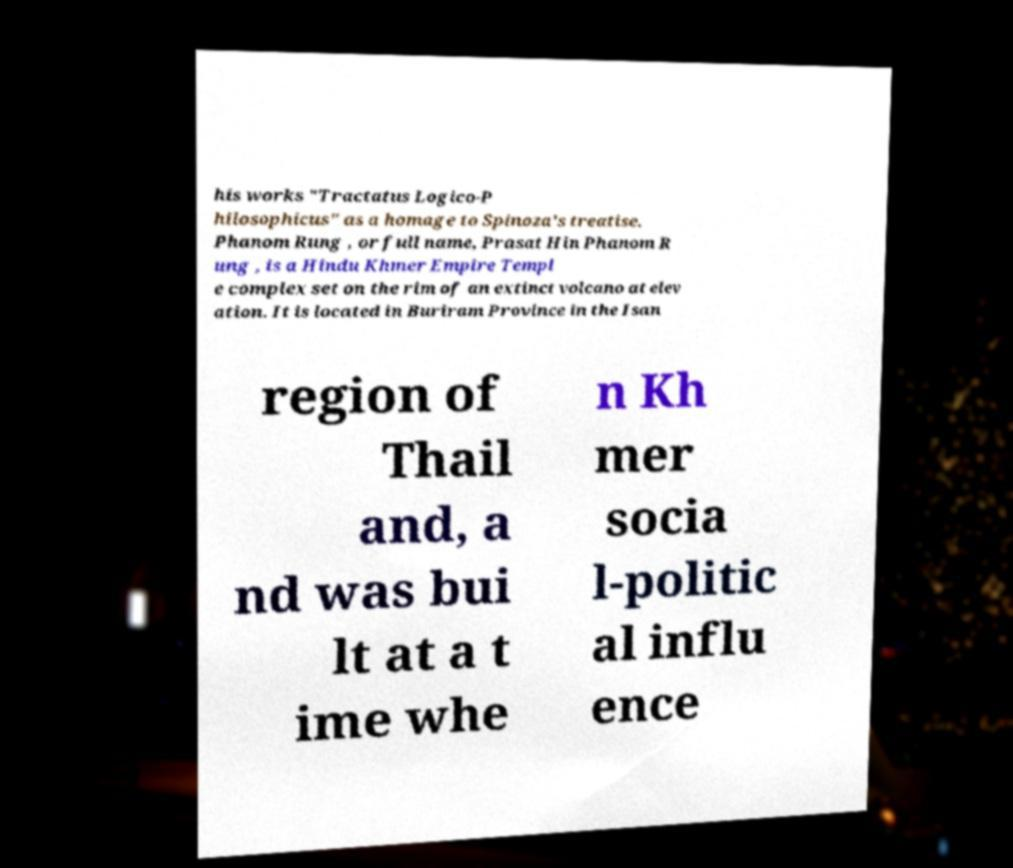What messages or text are displayed in this image? I need them in a readable, typed format. his works "Tractatus Logico-P hilosophicus" as a homage to Spinoza's treatise. Phanom Rung , or full name, Prasat Hin Phanom R ung , is a Hindu Khmer Empire Templ e complex set on the rim of an extinct volcano at elev ation. It is located in Buriram Province in the Isan region of Thail and, a nd was bui lt at a t ime whe n Kh mer socia l-politic al influ ence 